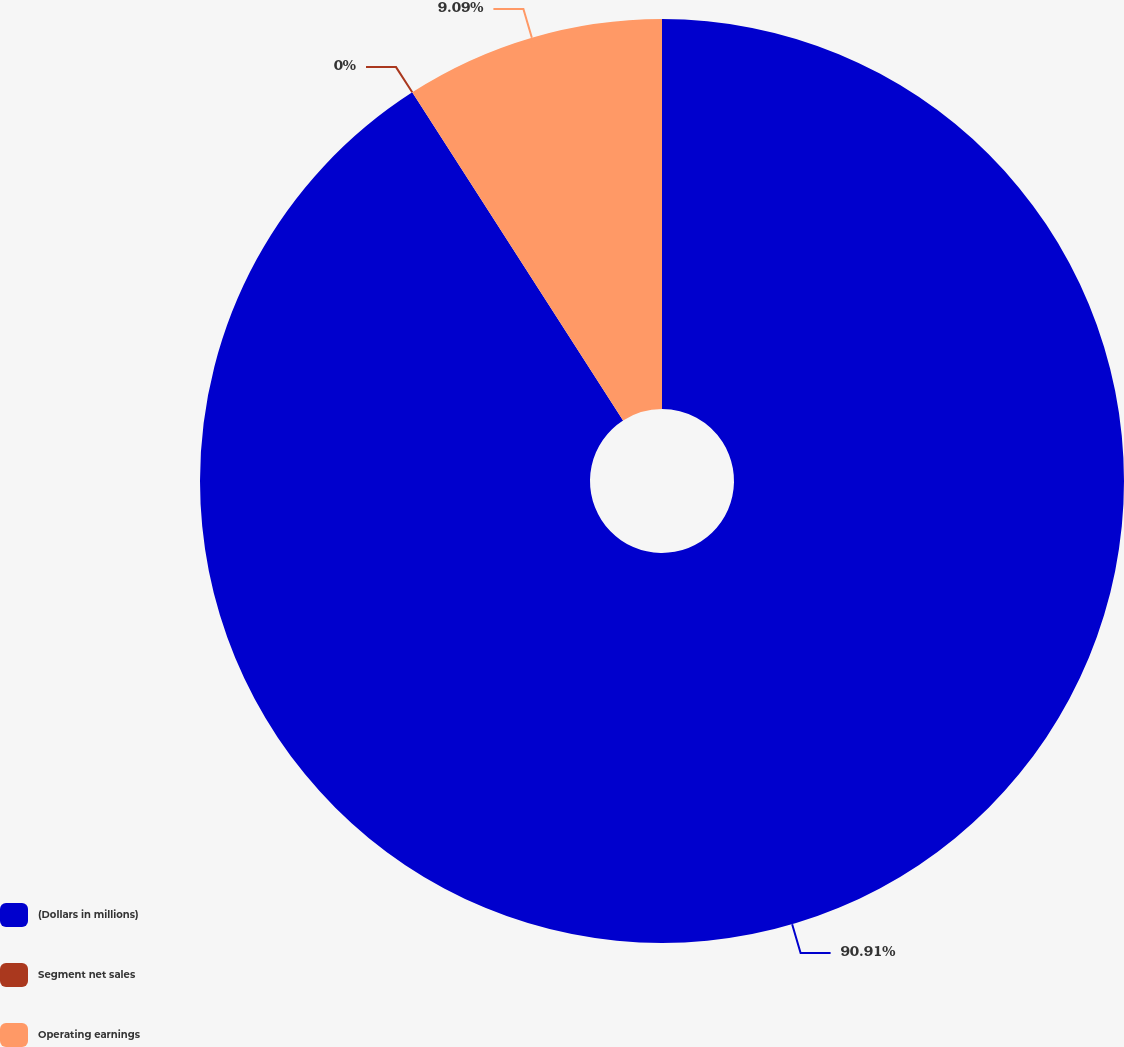Convert chart. <chart><loc_0><loc_0><loc_500><loc_500><pie_chart><fcel>(Dollars in millions)<fcel>Segment net sales<fcel>Operating earnings<nl><fcel>90.91%<fcel>0.0%<fcel>9.09%<nl></chart> 